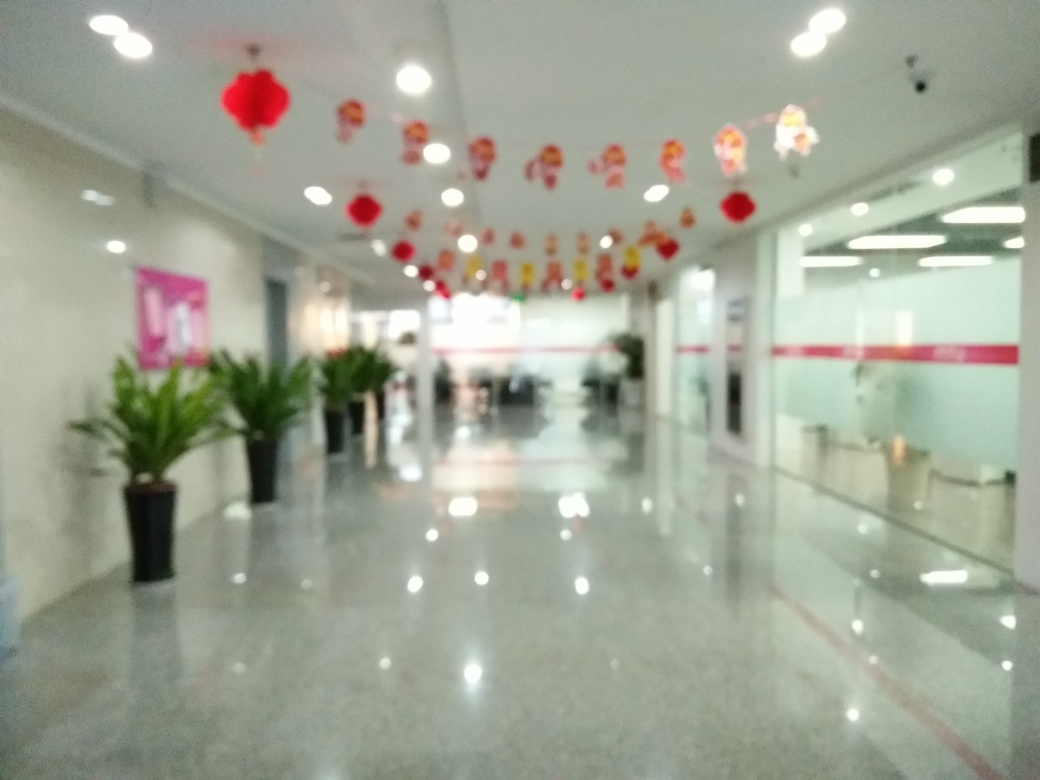What might be the reason for the blurriness in this photo? The blurriness in the photo could be due to a number of reasons. It might be the result of a camera shake during a long exposure, improper focus settings, or a low-quality camera lens. It could also be an artistic choice by the photographer to create a dreamlike or ethereal effect. However, without more context, it's difficult to determine the precise cause. If this was unintentional, the photographer might consider stabilizing the camera or adjusting the focus settings for a sharper image in future shots. 